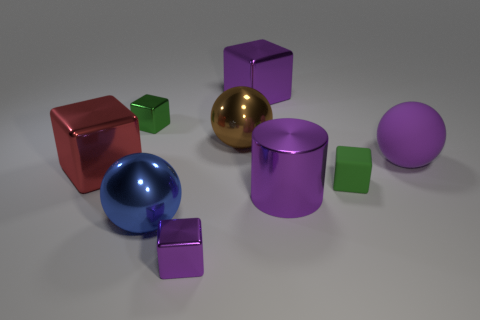Subtract all small purple metal cubes. How many cubes are left? 4 Subtract 1 blocks. How many blocks are left? 4 Subtract all red blocks. How many blocks are left? 4 Subtract all brown cubes. Subtract all yellow cylinders. How many cubes are left? 5 Subtract all balls. How many objects are left? 6 Add 1 big brown metal spheres. How many objects exist? 10 Add 7 matte balls. How many matte balls are left? 8 Add 1 large yellow rubber cylinders. How many large yellow rubber cylinders exist? 1 Subtract 0 gray cylinders. How many objects are left? 9 Subtract all big gray matte objects. Subtract all large brown balls. How many objects are left? 8 